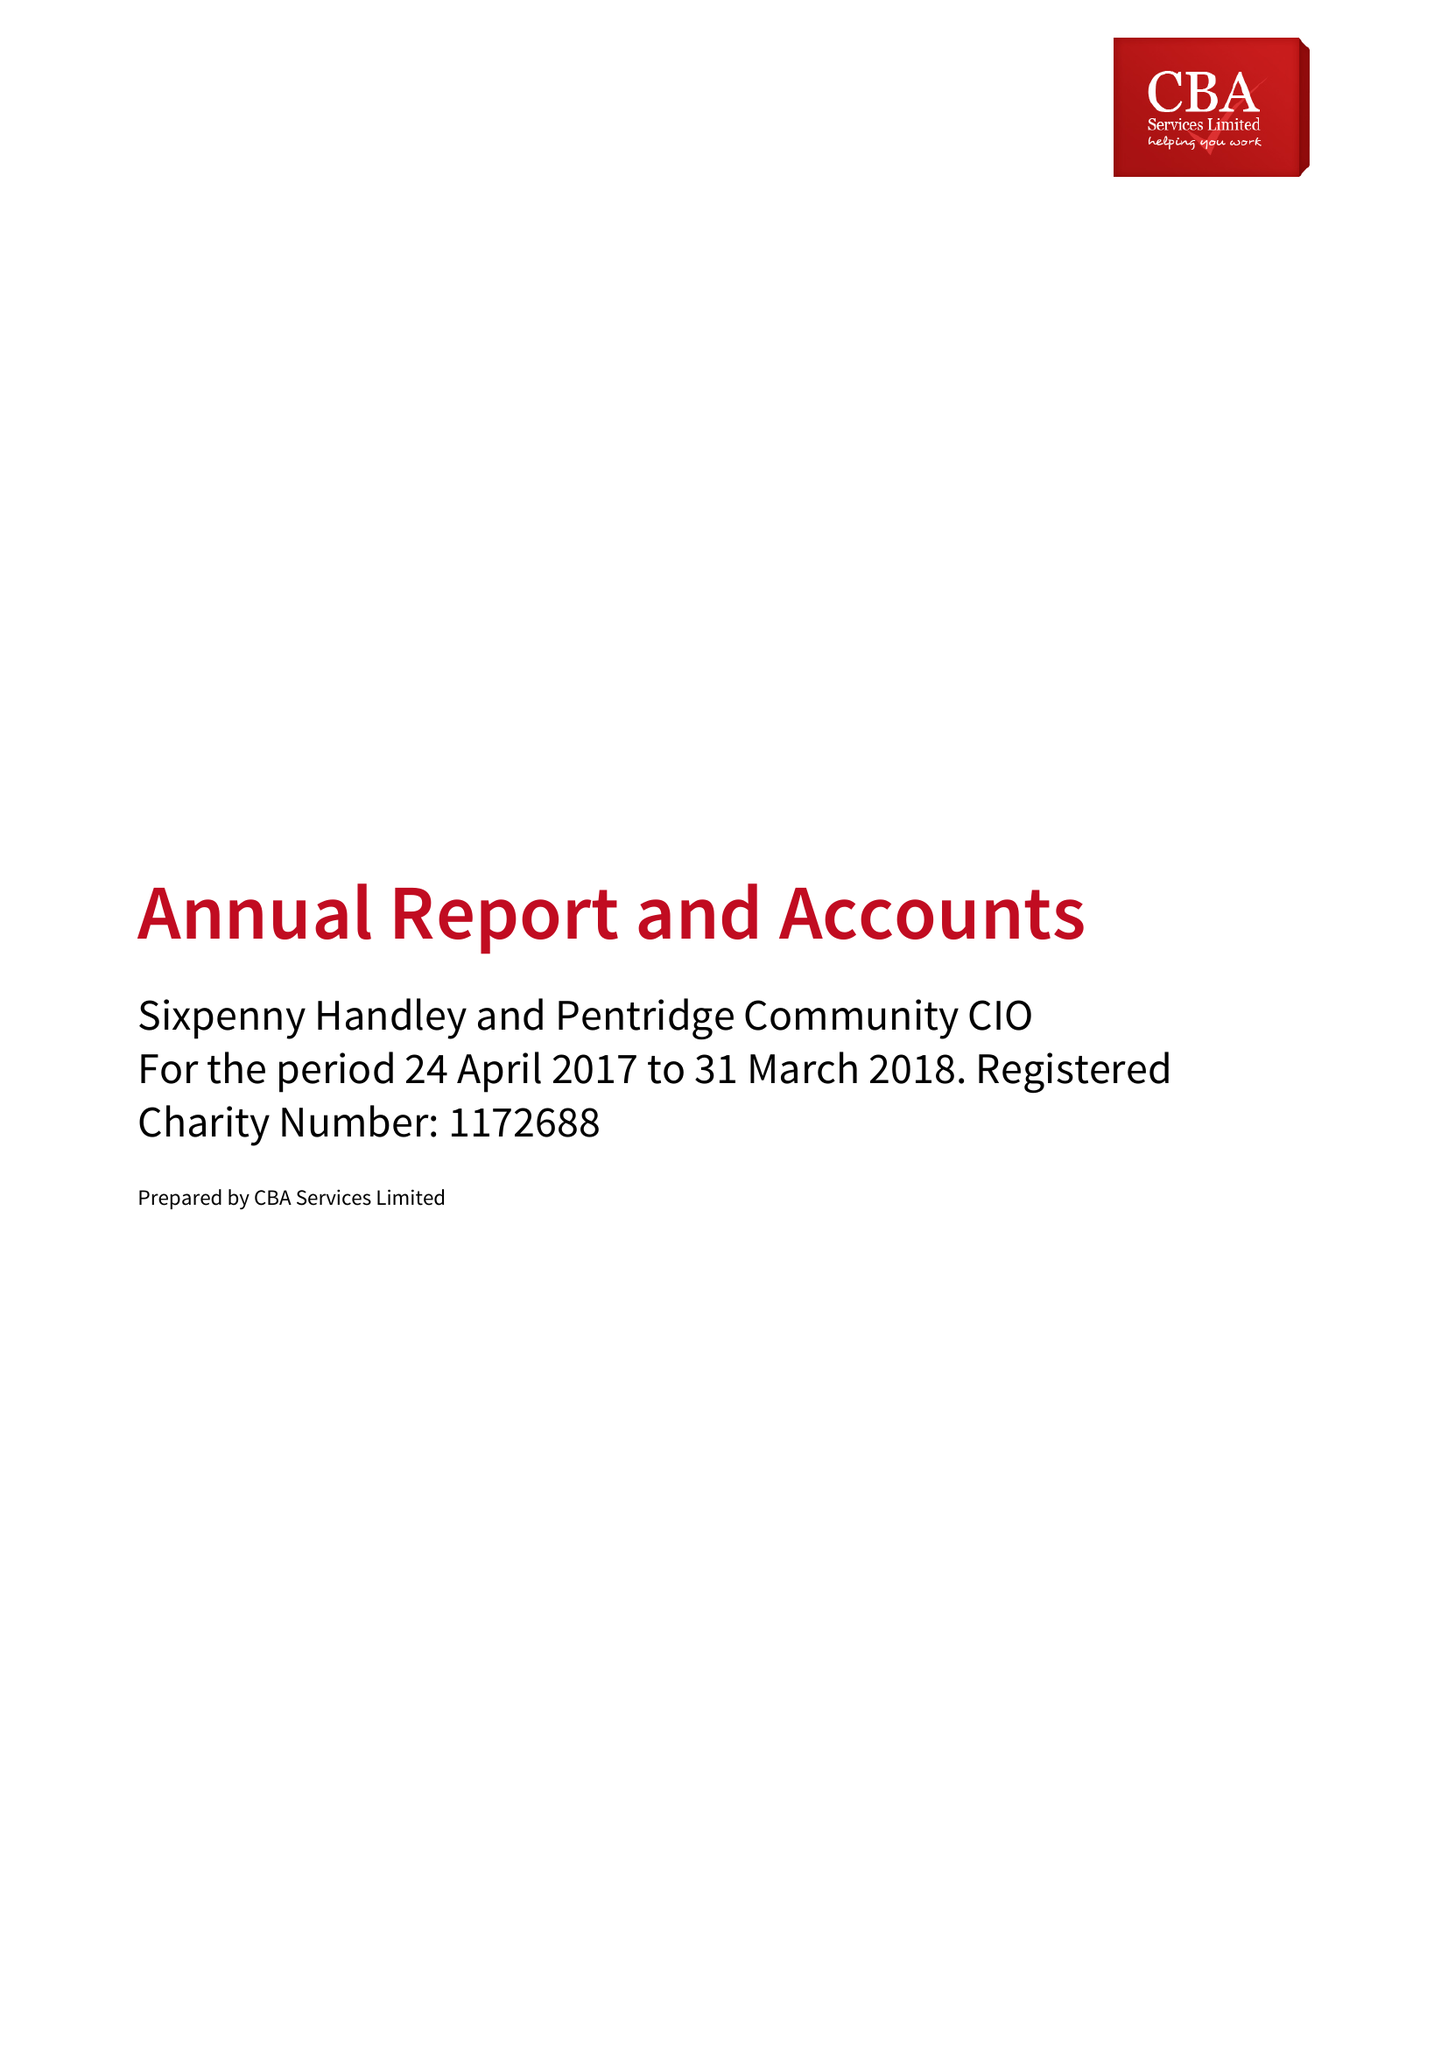What is the value for the charity_number?
Answer the question using a single word or phrase. 1172688 